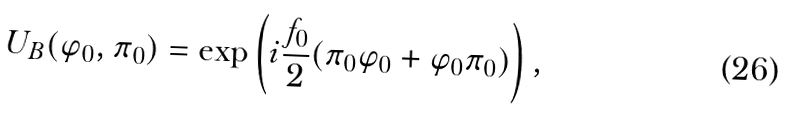Convert formula to latex. <formula><loc_0><loc_0><loc_500><loc_500>U _ { B } ( \varphi _ { 0 } , \pi _ { 0 } ) = \exp \left ( i \frac { f _ { 0 } } { 2 } ( \pi _ { 0 } \varphi _ { 0 } + \varphi _ { 0 } \pi _ { 0 } ) \right ) ,</formula> 